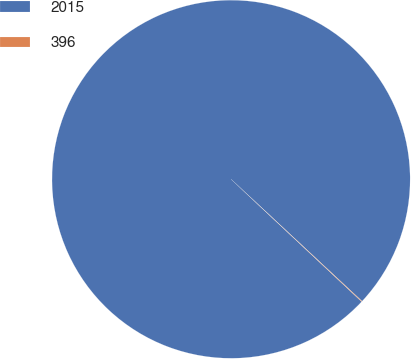<chart> <loc_0><loc_0><loc_500><loc_500><pie_chart><fcel>2015<fcel>396<nl><fcel>99.95%<fcel>0.05%<nl></chart> 